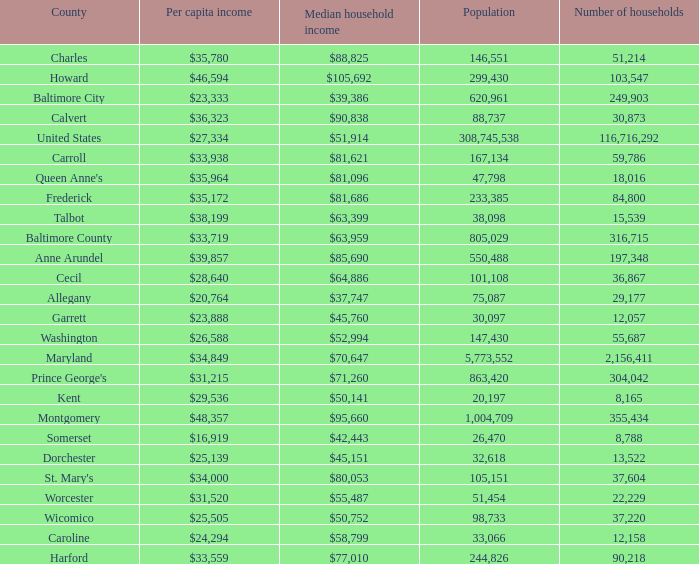What is the per capital income for Charles county? $35,780. 